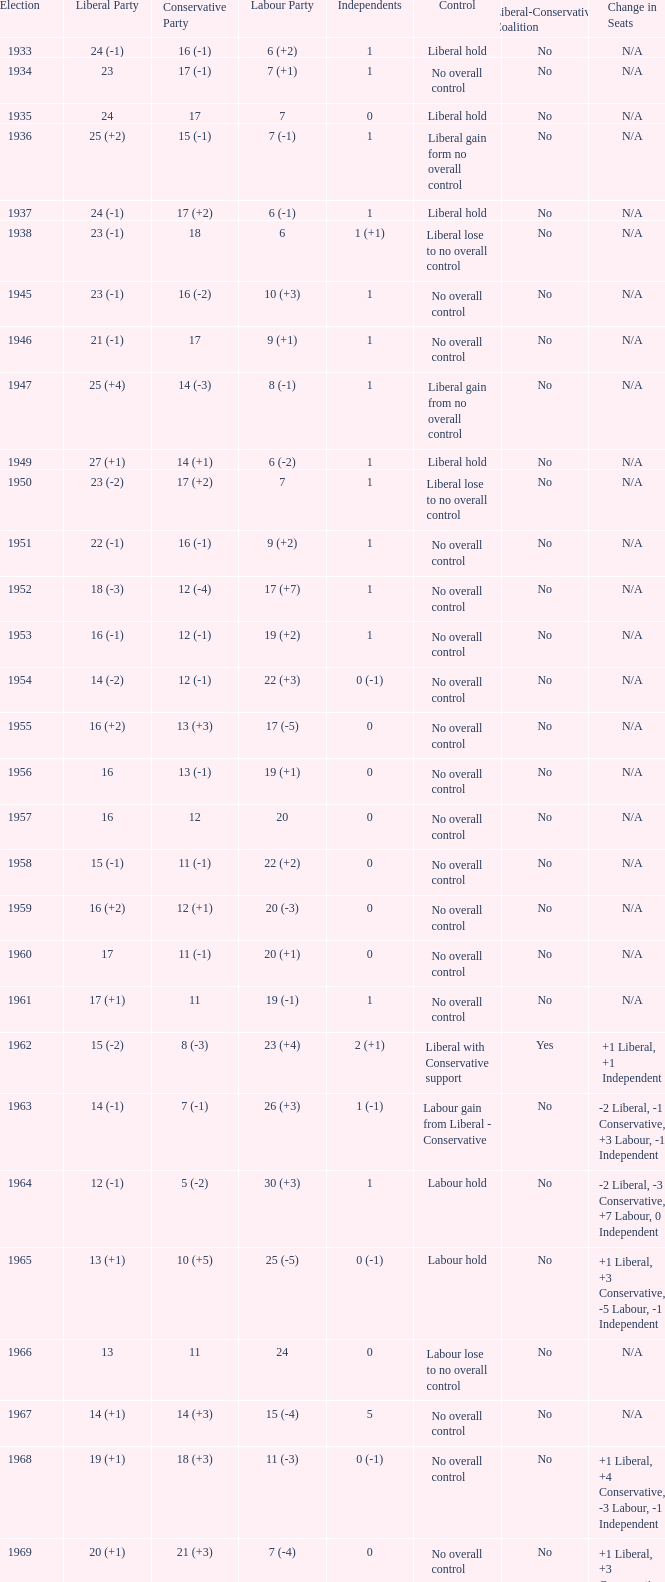What was the control for the year with a Conservative Party result of 10 (+5)? Labour hold. 